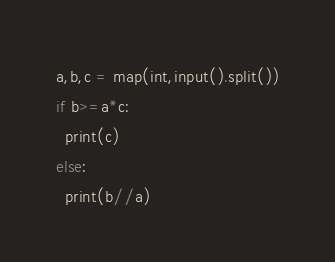<code> <loc_0><loc_0><loc_500><loc_500><_Python_>a,b,c = map(int,input().split())
if b>=a*c:
  print(c)
else:
  print(b//a)</code> 